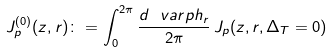Convert formula to latex. <formula><loc_0><loc_0><loc_500><loc_500>J _ { p } ^ { ( 0 ) } ( z , r ) \colon = \int _ { 0 } ^ { 2 \pi } \frac { d \ v a r p h _ { r } } { 2 \pi } \, J _ { p } ( z , { r } , \Delta _ { T } = 0 )</formula> 